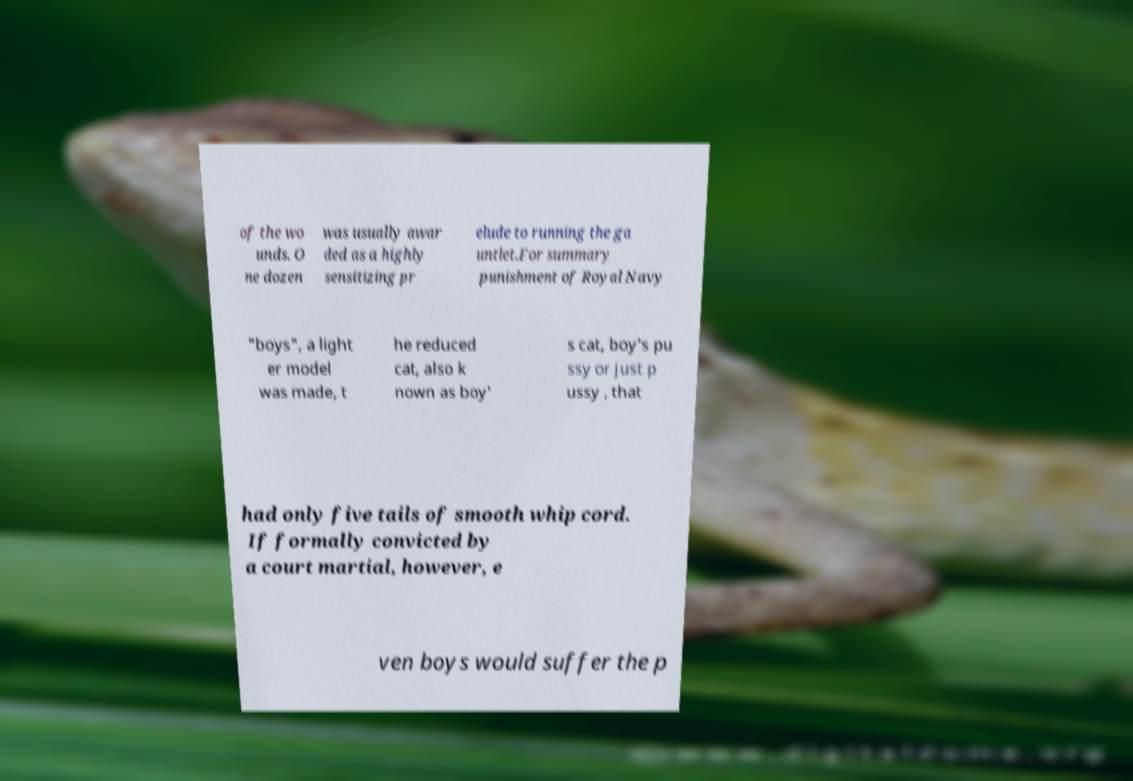Can you accurately transcribe the text from the provided image for me? of the wo unds. O ne dozen was usually awar ded as a highly sensitizing pr elude to running the ga untlet.For summary punishment of Royal Navy "boys", a light er model was made, t he reduced cat, also k nown as boy' s cat, boy's pu ssy or just p ussy , that had only five tails of smooth whip cord. If formally convicted by a court martial, however, e ven boys would suffer the p 